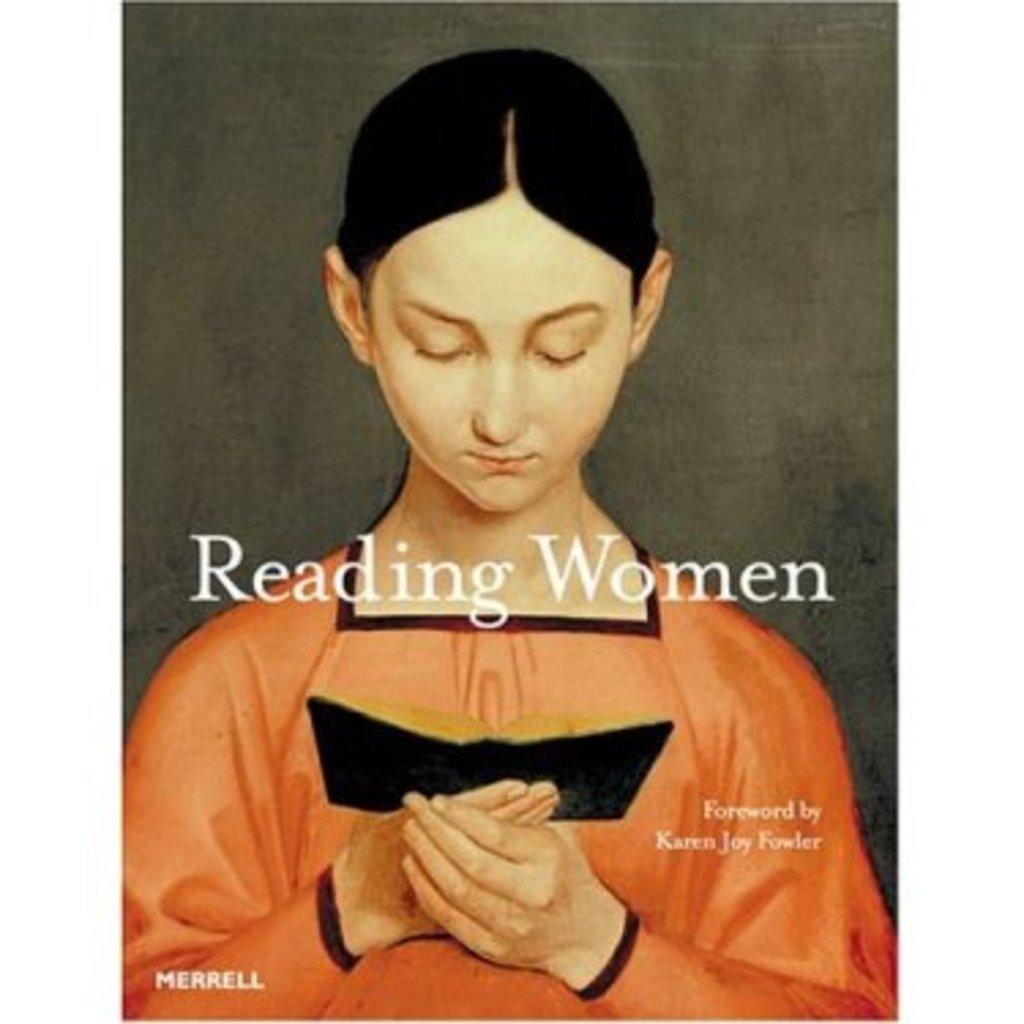Could you give a brief overview of what you see in this image? Here we can see a woman holding a book and we can see text. Background it is grey color. 